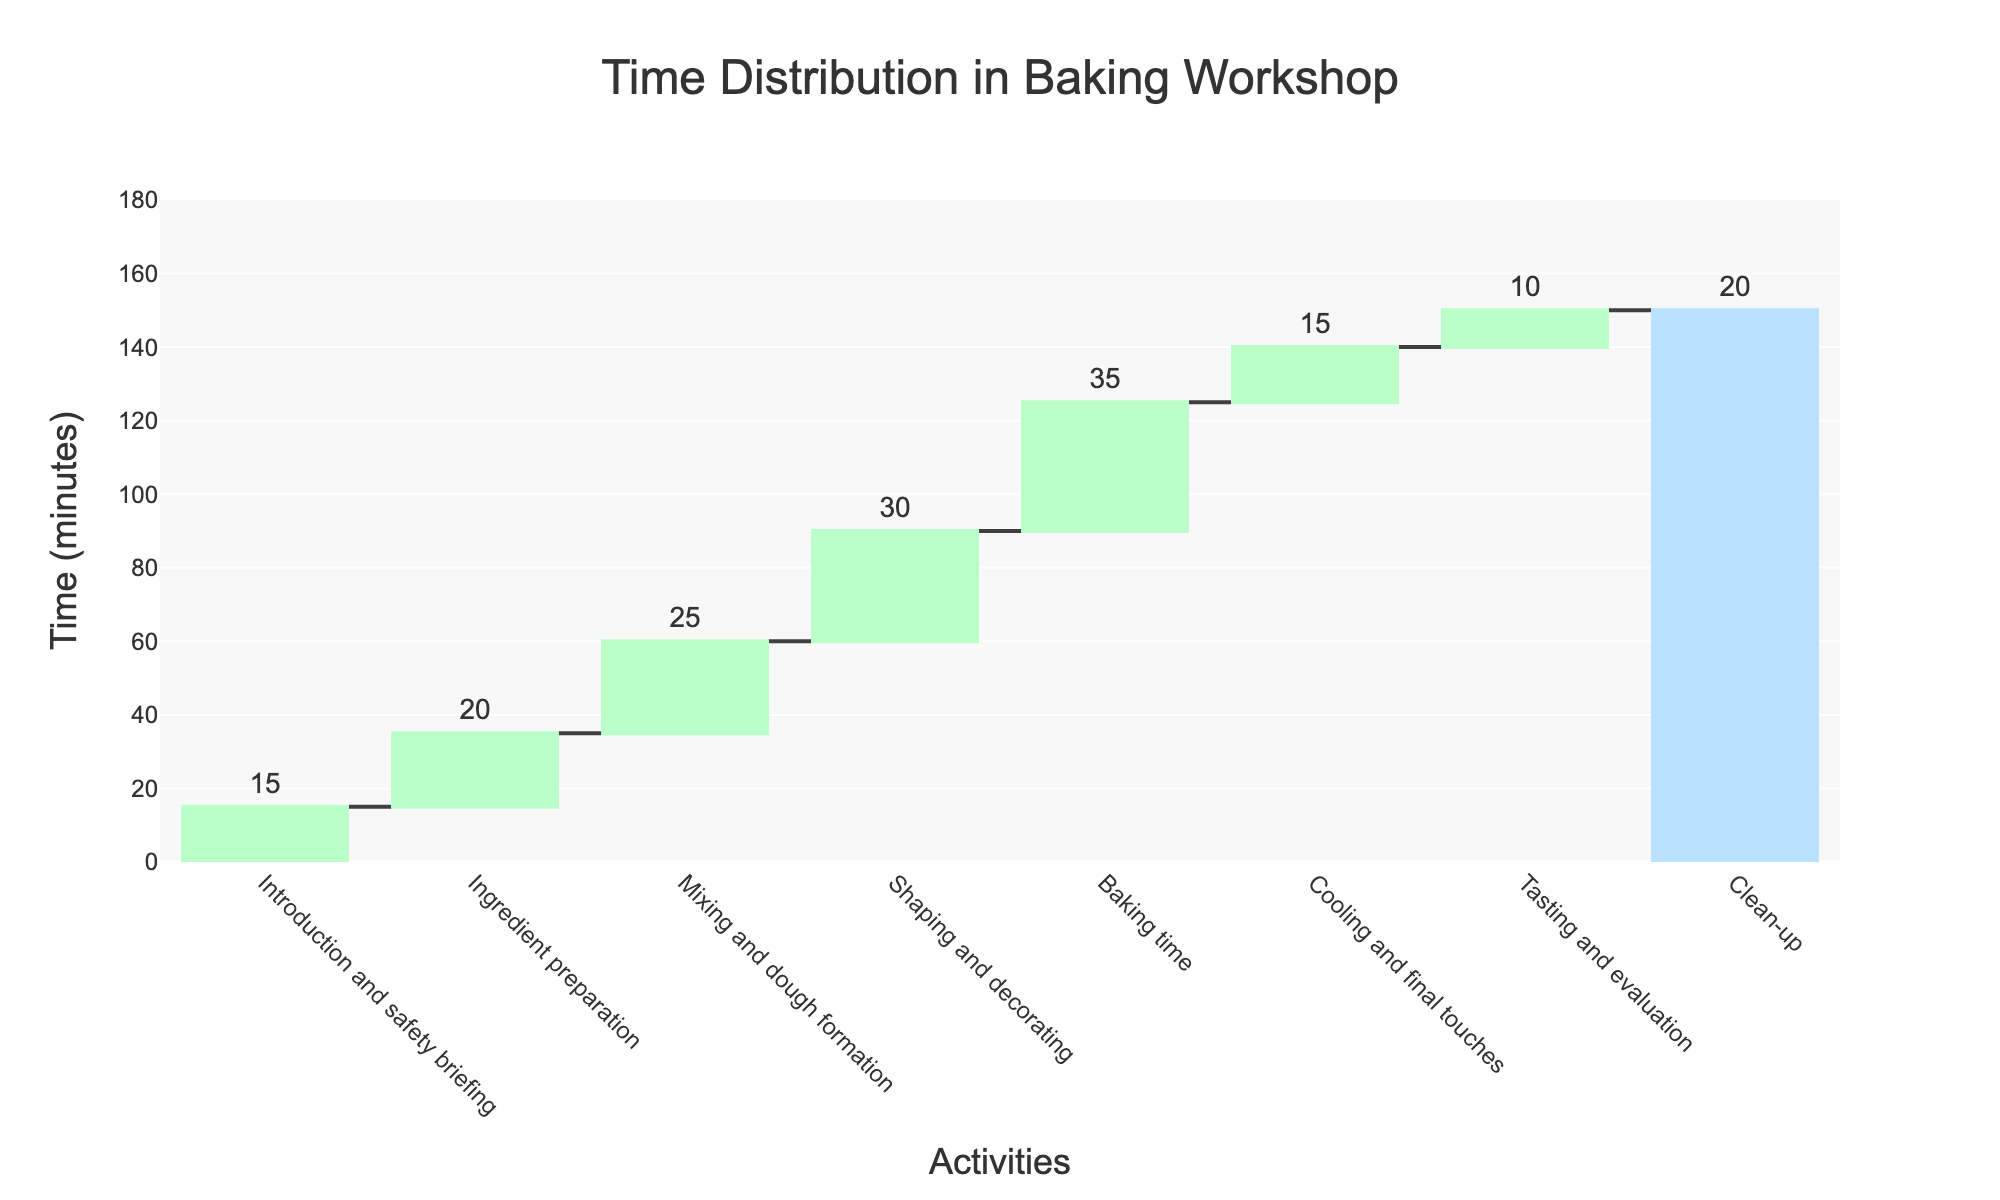what is the title of the chart? The title of the chart is typically found at the top of the figure. In this case, it states, "Time Distribution in Baking Workshop."
Answer: Time Distribution in Baking Workshop How long do the Ingredient preparation and Mixing and dough formation activities together take? To find the combined duration, add the time for Ingredient preparation (20 minutes) to the time for Mixing and dough formation (25 minutes). So, 20 + 25 = 45 minutes.
Answer: 45 minutes Which activity takes the longest time in the workshop? By observing the lengths of the bars corresponding to each activity, the one with the maximum length is Baking time, which is 35 minutes.
Answer: Baking time How does the time spent on Tasting and evaluation compare to the time spent on Clean-up? Comparing the bar lengths, Tasting and evaluation takes 10 minutes, whereas Clean-up takes 20 minutes. Therefore, Clean-up takes 10 minutes more than Tasting and evaluation.
Answer: Clean-up takes 10 minutes more What is the total duration of all activities excluding Tasting and evaluation? The durations of all activities except Tasting and evaluation are 15 (Introduction) + 20 (Ingredient prep) + 25 (Mixing) + 30 (Shaping) + 35 (Baking) + 15 (Cooling) + 20 (Clean-up). Sum these values: 15 + 20 + 25 + 30 + 35 + 15 + 20 = 160 minutes.
Answer: 160 minutes Which two activities combined take up the same amount of time as Baking time? Baking time is 35 minutes. The two activities that sum up to 35 are Introduction and safety briefing (15 minutes) and Clean-up (20 minutes), since 15 + 20 = 35.
Answer: Introduction and safety briefing and Clean-up What time interval is used for each measure in the chart? The time interval indicated in the chart's legend is 20 minutes.
Answer: 20 minutes What is the average time spent per activity, excluding the Total workshop duration? First, add up the times of individual activities: 15 + 20 + 25 + 30 + 35 + 15 + 10 + 20 = 170 minutes. There are 8 activities. The average is 170 / 8 = 21.25 minutes.
Answer: 21.25 minutes If the Baking time was reduced by 10 minutes, what would be the new total workshop duration? The original Baking time is 35 minutes. If it is reduced by 10 minutes, it becomes 25 minutes. The new total is 170 - 10 = 160 minutes.
Answer: 160 minutes What percentage of the total workshop duration is spent on Shaping and decorating? Shaping and decorating takes 30 minutes. The total workshop duration is 170 minutes. The percentage is (30 / 170) * 100 = approximately 17.65%.
Answer: Approximately 17.65% 